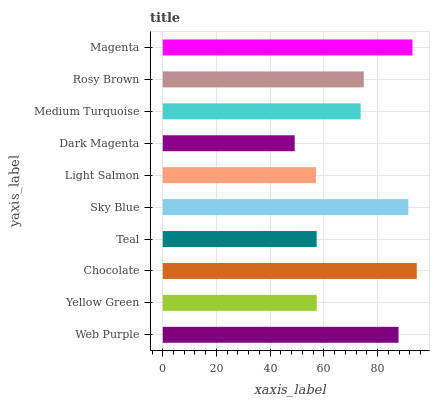Is Dark Magenta the minimum?
Answer yes or no. Yes. Is Chocolate the maximum?
Answer yes or no. Yes. Is Yellow Green the minimum?
Answer yes or no. No. Is Yellow Green the maximum?
Answer yes or no. No. Is Web Purple greater than Yellow Green?
Answer yes or no. Yes. Is Yellow Green less than Web Purple?
Answer yes or no. Yes. Is Yellow Green greater than Web Purple?
Answer yes or no. No. Is Web Purple less than Yellow Green?
Answer yes or no. No. Is Rosy Brown the high median?
Answer yes or no. Yes. Is Medium Turquoise the low median?
Answer yes or no. Yes. Is Light Salmon the high median?
Answer yes or no. No. Is Web Purple the low median?
Answer yes or no. No. 